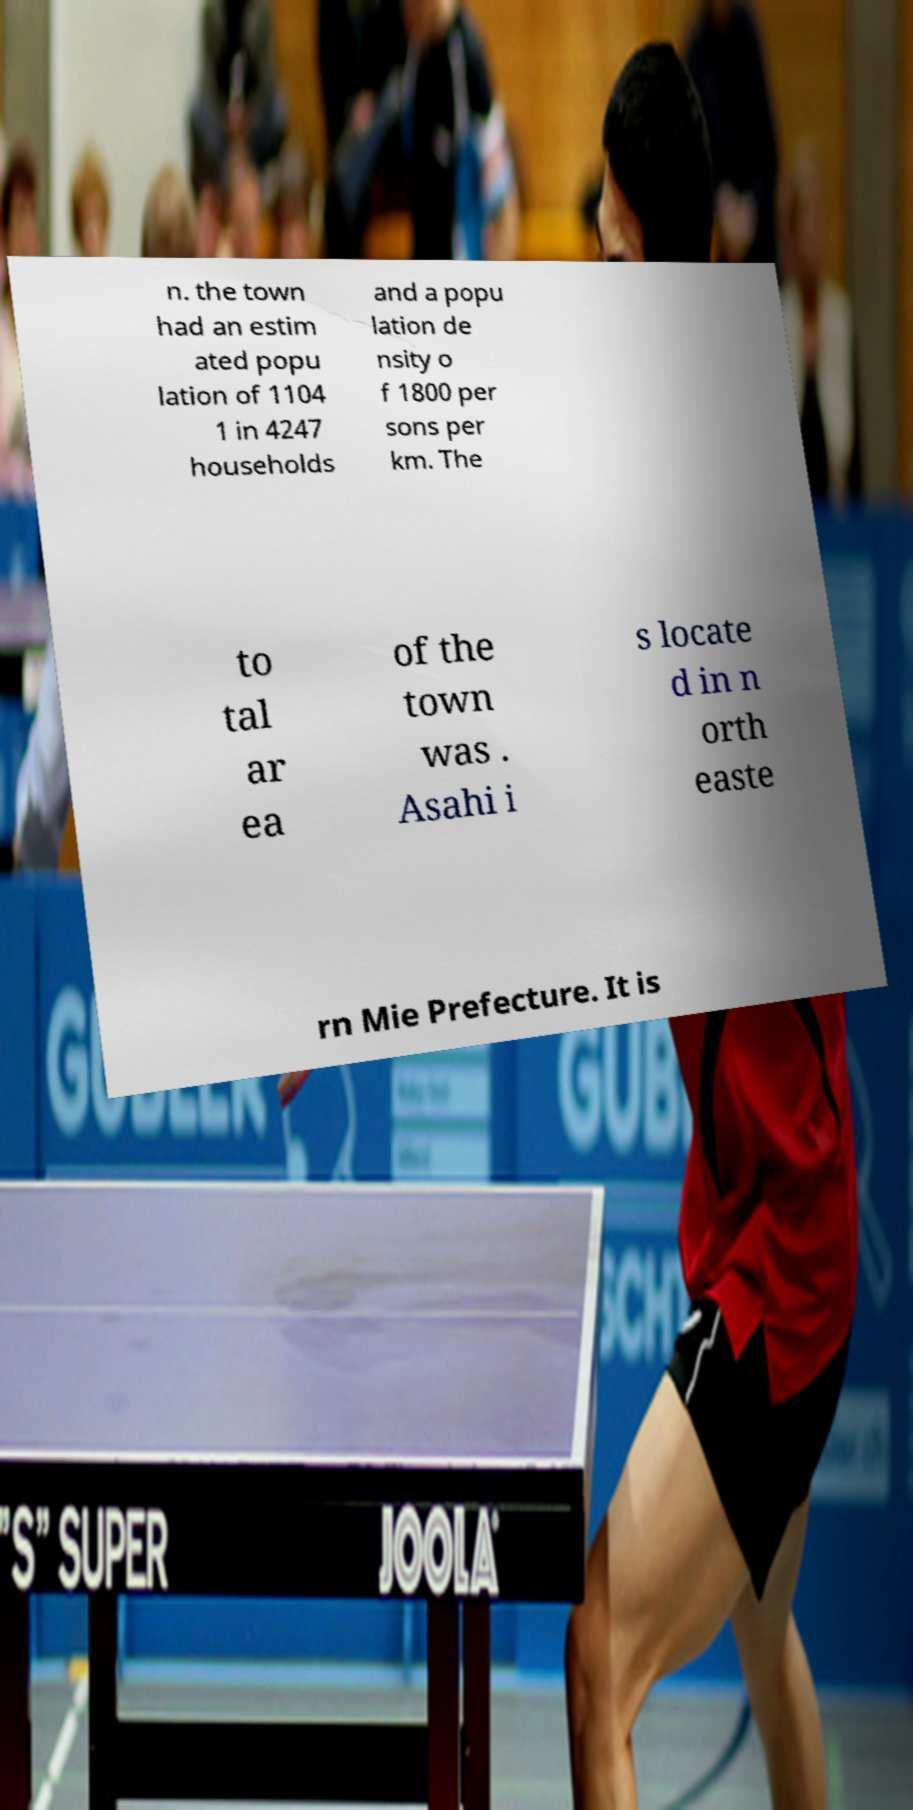I need the written content from this picture converted into text. Can you do that? n. the town had an estim ated popu lation of 1104 1 in 4247 households and a popu lation de nsity o f 1800 per sons per km. The to tal ar ea of the town was . Asahi i s locate d in n orth easte rn Mie Prefecture. It is 